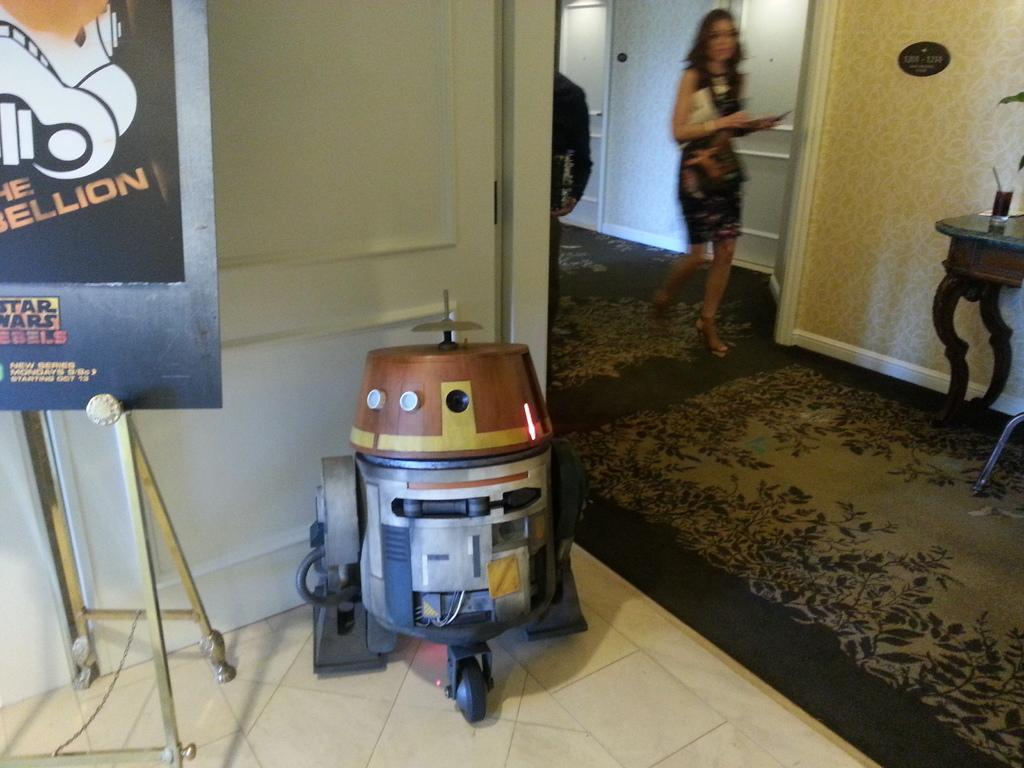<image>
Write a terse but informative summary of the picture. A cute little robot is on display next to a Star Wars poster. 